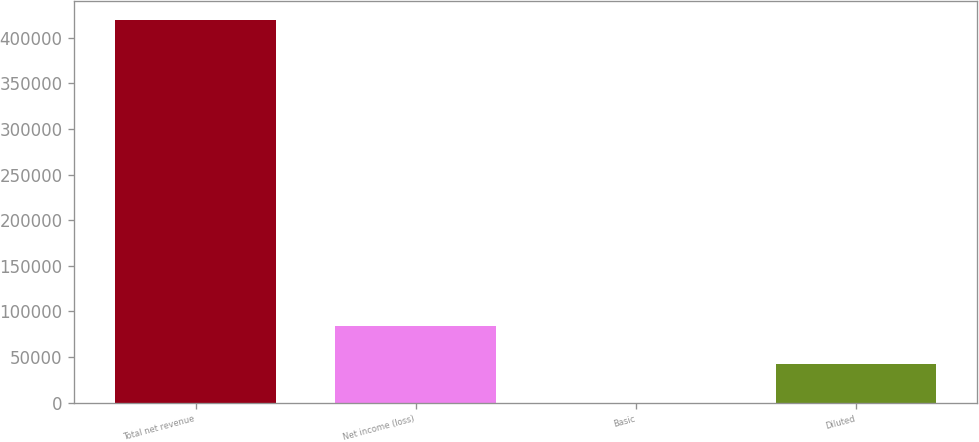Convert chart to OTSL. <chart><loc_0><loc_0><loc_500><loc_500><bar_chart><fcel>Total net revenue<fcel>Net income (loss)<fcel>Basic<fcel>Diluted<nl><fcel>419865<fcel>83973.1<fcel>0.12<fcel>41986.6<nl></chart> 